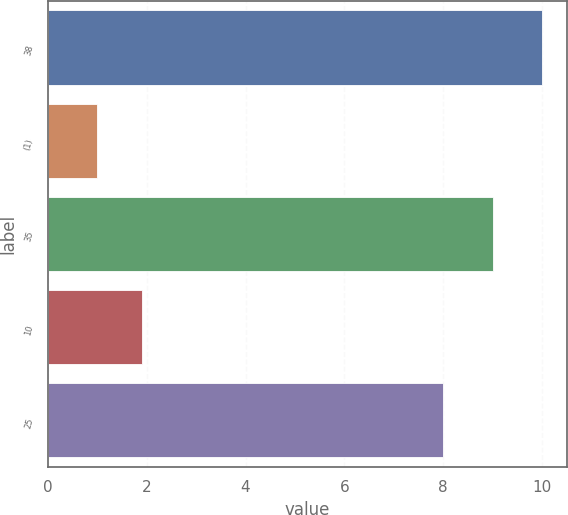<chart> <loc_0><loc_0><loc_500><loc_500><bar_chart><fcel>38<fcel>(1)<fcel>35<fcel>10<fcel>25<nl><fcel>10<fcel>1<fcel>9<fcel>1.9<fcel>8<nl></chart> 